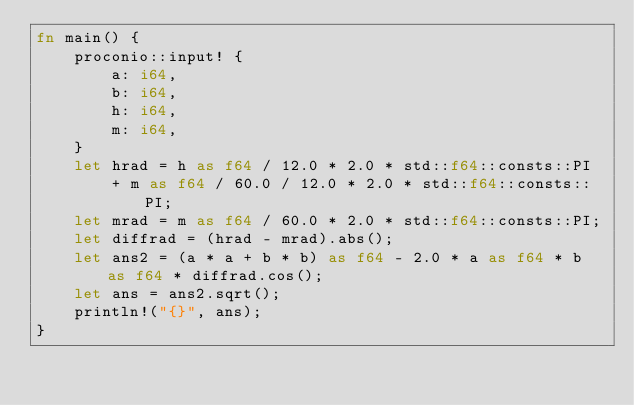Convert code to text. <code><loc_0><loc_0><loc_500><loc_500><_Rust_>fn main() {
    proconio::input! {
        a: i64,
        b: i64,
        h: i64,
        m: i64,
    }
    let hrad = h as f64 / 12.0 * 2.0 * std::f64::consts::PI
        + m as f64 / 60.0 / 12.0 * 2.0 * std::f64::consts::PI;
    let mrad = m as f64 / 60.0 * 2.0 * std::f64::consts::PI;
    let diffrad = (hrad - mrad).abs();
    let ans2 = (a * a + b * b) as f64 - 2.0 * a as f64 * b as f64 * diffrad.cos();
    let ans = ans2.sqrt();
    println!("{}", ans);
}
</code> 